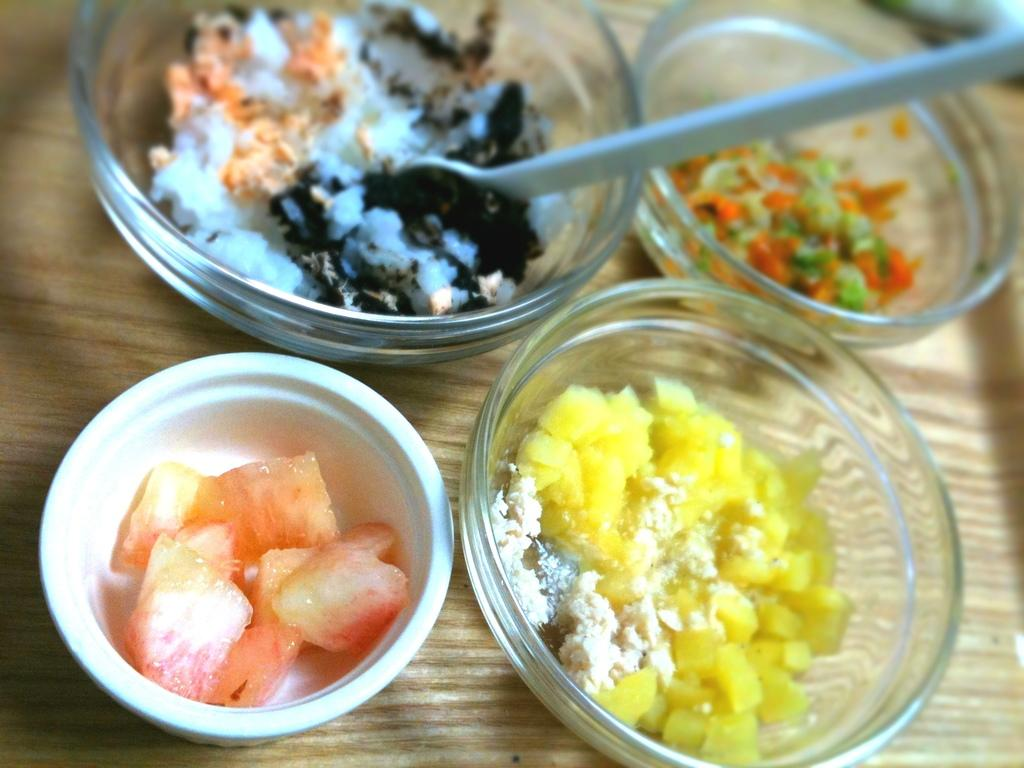What is the main piece of furniture in the image? There is a table in the image. How many bowls are on the table? There are four bowls on the table. What is in each of the bowls? Each bowl contains a food item. What type of trees can be seen in the middle of the image? There are no trees present in the image; it only features a table with four bowls. 